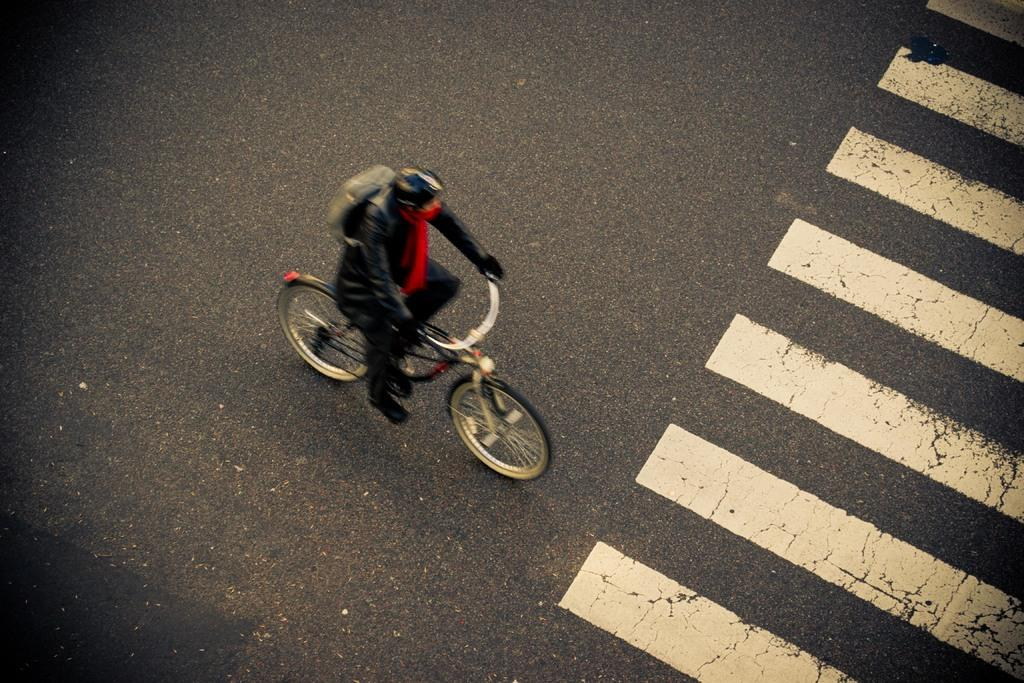What is the person in the image doing? The person is riding a bicycle in the image. What can be seen in the background of the image? There is a road in the image. What is the person wearing? The person is wearing a black dress and a backpack. What safety feature is present on the road in the image? There is a zebra crossing on the right side of the image. Can you see a plough being used in the image? No, there is no plough present in the image. How many roses can be seen in the person's hand in the image? There are no roses visible in the image; the person is riding a bicycle and wearing a backpack. 